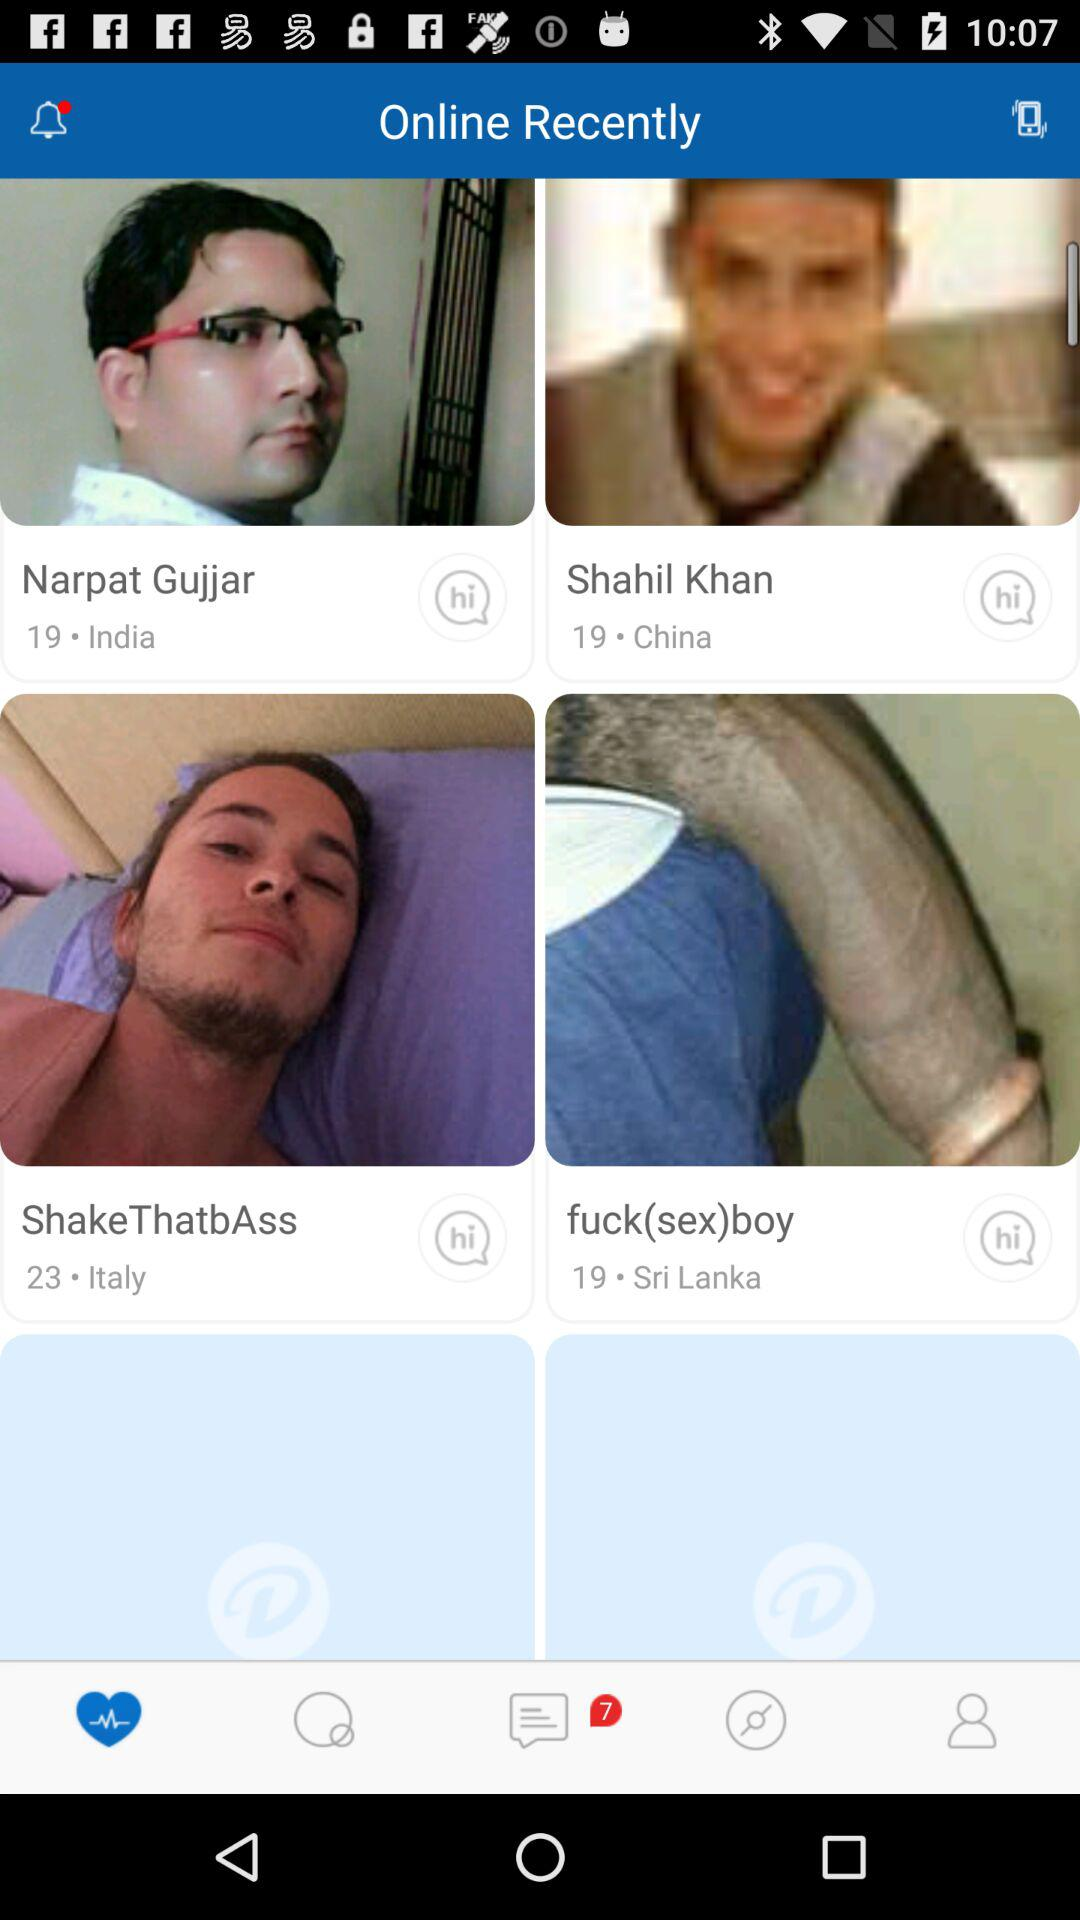What application can be used to log in with? The application that can be used to log in is "Facebook". 